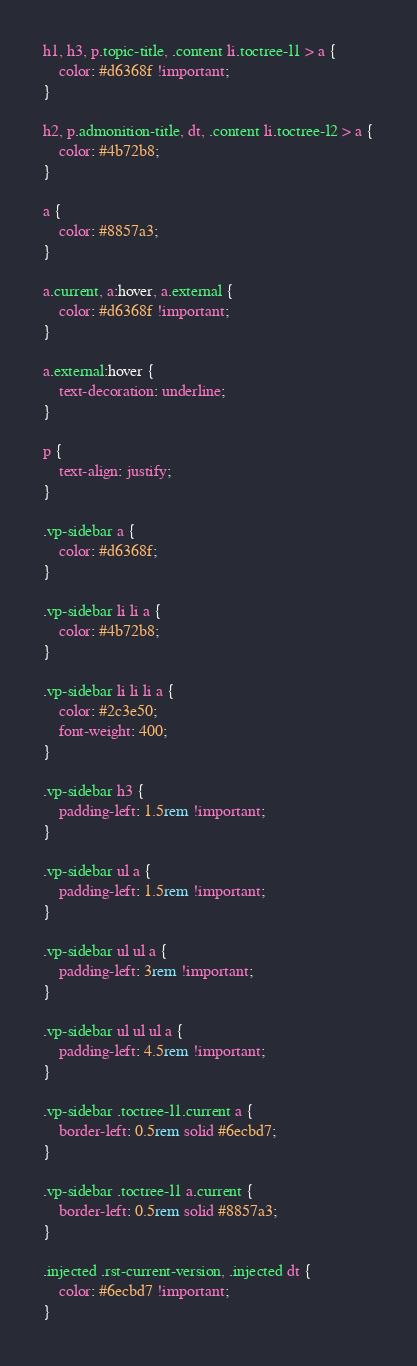Convert code to text. <code><loc_0><loc_0><loc_500><loc_500><_CSS_>h1, h3, p.topic-title, .content li.toctree-l1 > a {
    color: #d6368f !important;
}

h2, p.admonition-title, dt, .content li.toctree-l2 > a {
    color: #4b72b8;
}

a {
    color: #8857a3;
}

a.current, a:hover, a.external {
    color: #d6368f !important;
}

a.external:hover {
    text-decoration: underline;
}

p {
    text-align: justify;
}

.vp-sidebar a {
    color: #d6368f;
}

.vp-sidebar li li a {
    color: #4b72b8;
}

.vp-sidebar li li li a {
    color: #2c3e50;
    font-weight: 400;
}

.vp-sidebar h3 {
    padding-left: 1.5rem !important;
}

.vp-sidebar ul a {
    padding-left: 1.5rem !important;
}

.vp-sidebar ul ul a {
    padding-left: 3rem !important;
}

.vp-sidebar ul ul ul a {
    padding-left: 4.5rem !important;
}

.vp-sidebar .toctree-l1.current a {
    border-left: 0.5rem solid #6ecbd7;
}

.vp-sidebar .toctree-l1 a.current {
    border-left: 0.5rem solid #8857a3;
}

.injected .rst-current-version, .injected dt {
    color: #6ecbd7 !important;
}
</code> 